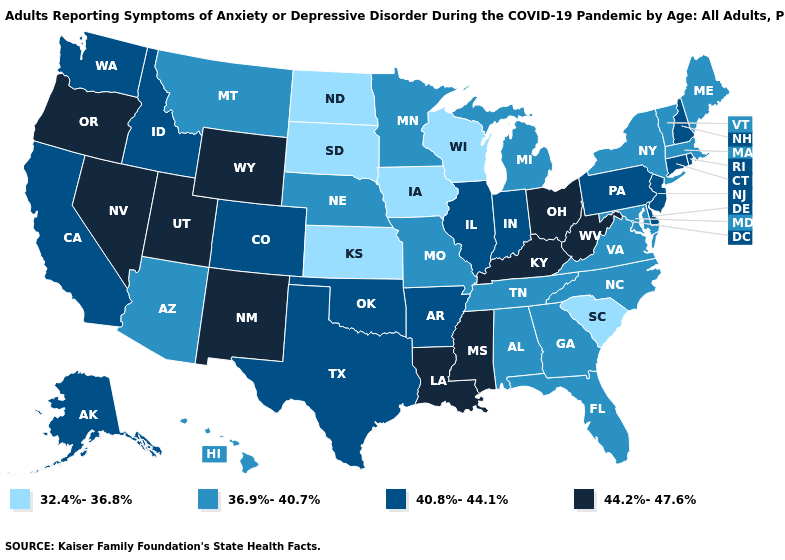Name the states that have a value in the range 32.4%-36.8%?
Write a very short answer. Iowa, Kansas, North Dakota, South Carolina, South Dakota, Wisconsin. How many symbols are there in the legend?
Write a very short answer. 4. Among the states that border Minnesota , which have the lowest value?
Quick response, please. Iowa, North Dakota, South Dakota, Wisconsin. How many symbols are there in the legend?
Quick response, please. 4. Name the states that have a value in the range 36.9%-40.7%?
Short answer required. Alabama, Arizona, Florida, Georgia, Hawaii, Maine, Maryland, Massachusetts, Michigan, Minnesota, Missouri, Montana, Nebraska, New York, North Carolina, Tennessee, Vermont, Virginia. Name the states that have a value in the range 36.9%-40.7%?
Give a very brief answer. Alabama, Arizona, Florida, Georgia, Hawaii, Maine, Maryland, Massachusetts, Michigan, Minnesota, Missouri, Montana, Nebraska, New York, North Carolina, Tennessee, Vermont, Virginia. Does West Virginia have the lowest value in the South?
Be succinct. No. What is the highest value in the MidWest ?
Concise answer only. 44.2%-47.6%. What is the value of Hawaii?
Give a very brief answer. 36.9%-40.7%. Does Montana have the same value as Minnesota?
Short answer required. Yes. What is the value of Florida?
Give a very brief answer. 36.9%-40.7%. Does Maine have the lowest value in the Northeast?
Short answer required. Yes. Name the states that have a value in the range 32.4%-36.8%?
Be succinct. Iowa, Kansas, North Dakota, South Carolina, South Dakota, Wisconsin. Is the legend a continuous bar?
Short answer required. No. What is the highest value in states that border North Carolina?
Give a very brief answer. 36.9%-40.7%. 